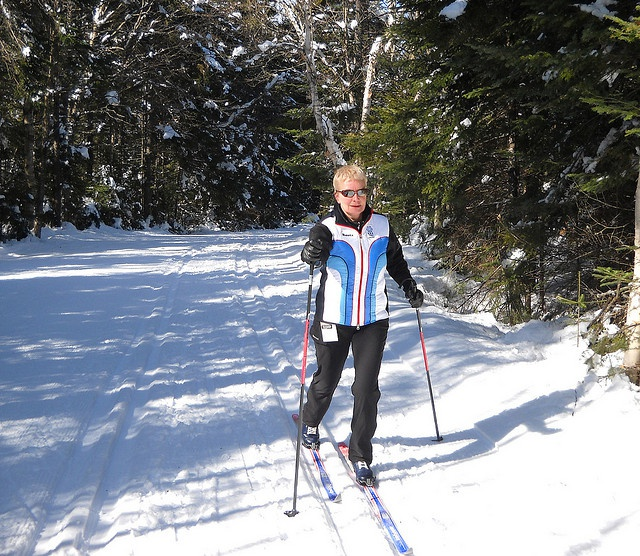Describe the objects in this image and their specific colors. I can see people in black, white, gray, and lightblue tones and skis in black, lightgray, lavender, darkgray, and gray tones in this image. 